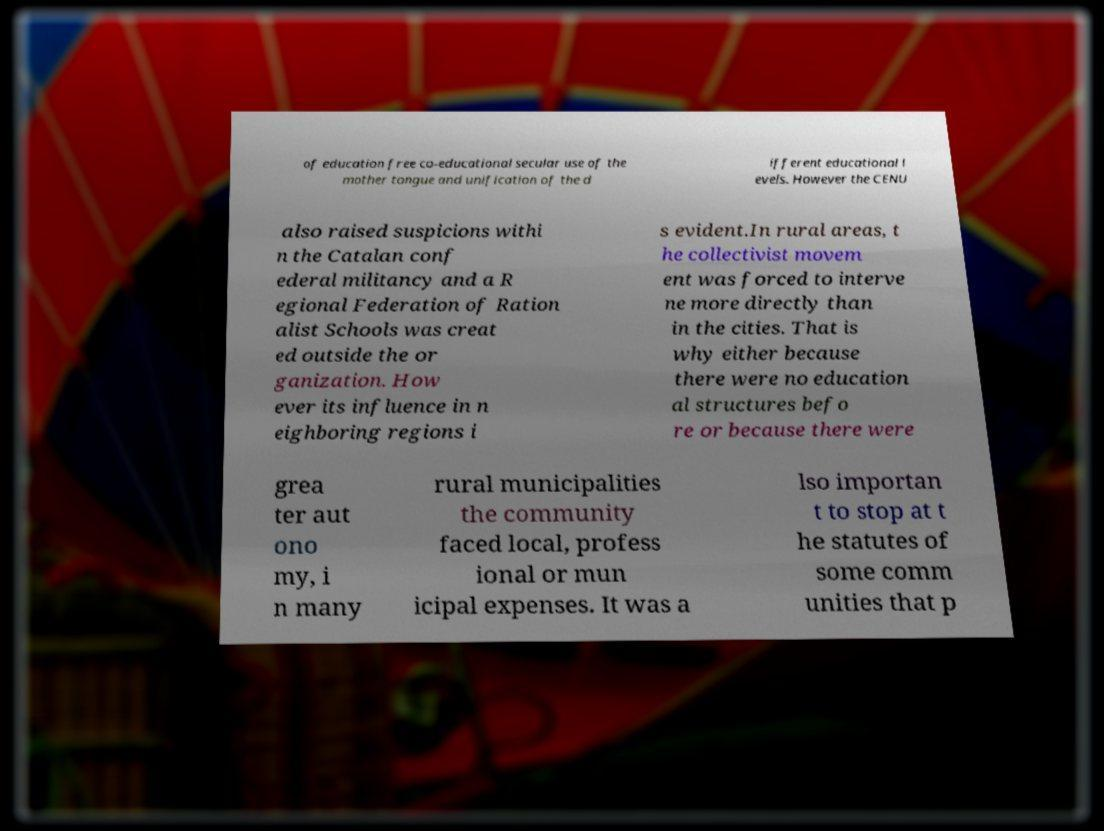There's text embedded in this image that I need extracted. Can you transcribe it verbatim? of education free co-educational secular use of the mother tongue and unification of the d ifferent educational l evels. However the CENU also raised suspicions withi n the Catalan conf ederal militancy and a R egional Federation of Ration alist Schools was creat ed outside the or ganization. How ever its influence in n eighboring regions i s evident.In rural areas, t he collectivist movem ent was forced to interve ne more directly than in the cities. That is why either because there were no education al structures befo re or because there were grea ter aut ono my, i n many rural municipalities the community faced local, profess ional or mun icipal expenses. It was a lso importan t to stop at t he statutes of some comm unities that p 